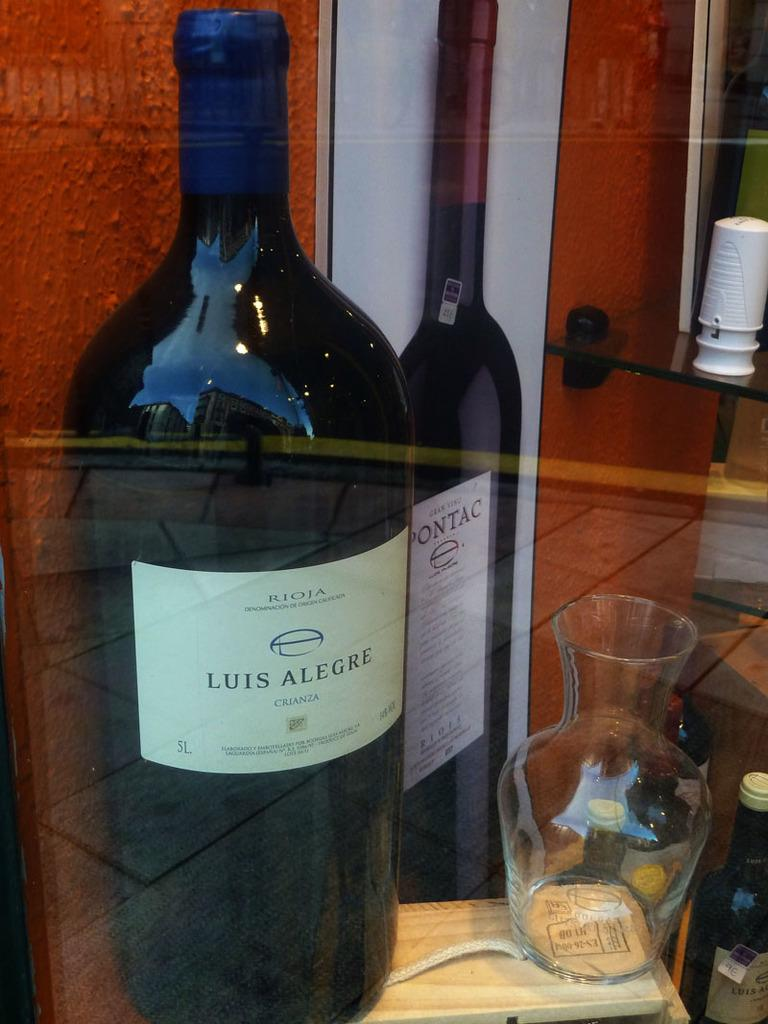<image>
Describe the image concisely. the bottle of Luis Alegre wine is sitting beside the carafe 